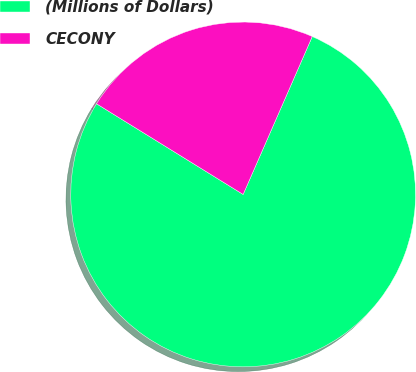Convert chart to OTSL. <chart><loc_0><loc_0><loc_500><loc_500><pie_chart><fcel>(Millions of Dollars)<fcel>CECONY<nl><fcel>77.25%<fcel>22.75%<nl></chart> 